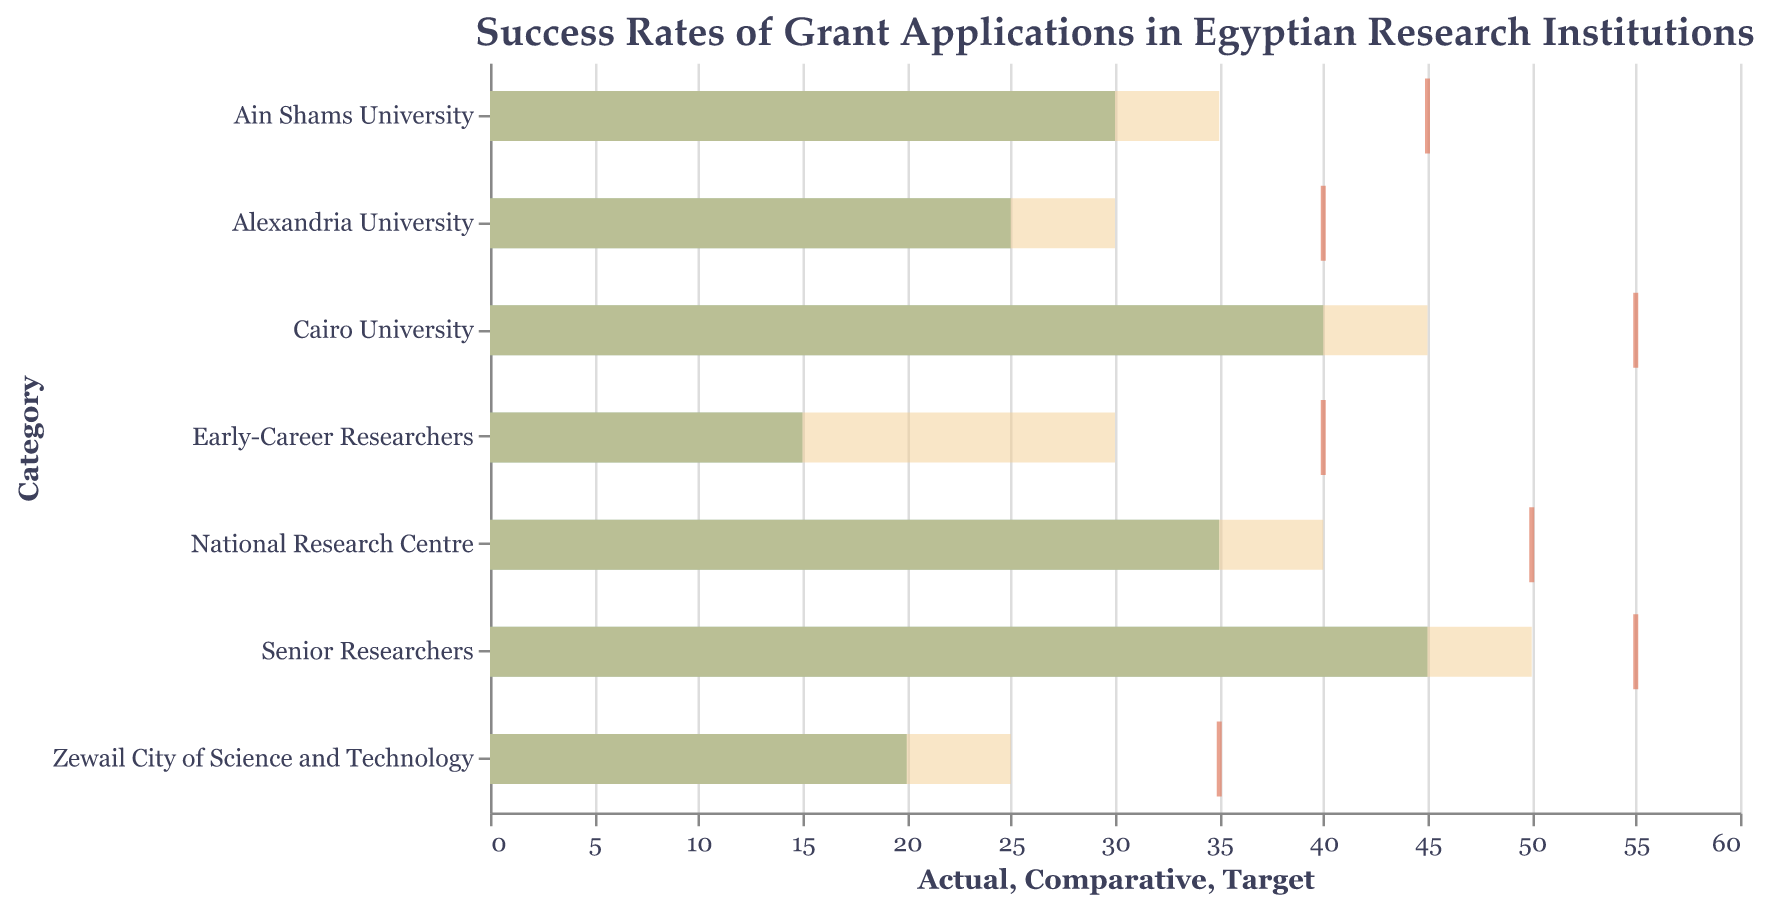What is the actual success rate for early-career researchers? Look at the "Actual" success rate bar associated with the "Early-Career Researchers" category.
Answer: 15 How does the actual success rate of senior researchers compare to the early-career researchers? Compare the "Actual" success rate bars for both categories. The senior researchers have 45, while the early-career researchers have 15.
Answer: Senior researchers have 30% higher success rate than early-career researchers Which institution has the lowest actual success rate? Look at the "Actual" success rate bars for all institutions. The institution with the smallest bar, "Zewail City of Science and Technology," has the lowest actual success rate.
Answer: Zewail City of Science and Technology Are any institutions meeting their target success rate? Compare the "Actual" success rate bars with their respective "Target" tick mark. None of the actual rates reach their target marks.
Answer: No What is the difference between the comparative and actual success rates for Cairo University? Subtract the "Actual" success rate from the "Comparative" success rate for Cairo University (45 - 40).
Answer: 5 Which institution is closest to meeting its target success rate? Compare the distances between the "Actual" success rate bars and the "Target" tick marks. Cairo University is the closest as it's 15% away from its target of 55.
Answer: Cairo University How does the success rate of Ain Shams University compare to Alexandria University in terms of their actual data? Look at the "Actual" success rate bars for both universities. Ain Shams University has 30, and Alexandria University has 25.
Answer: Ain Shams University's rate is 5% higher What is the combined actual success rate of the National Research Centre and Zewail City of Science and Technology? Add the "Actual" success rates for both categories (35 + 20).
Answer: 55 Which category or institution has the highest actual success rate? Identify the tallest "Actual" success rate bar in the chart. The "Senior Researchers" category has the highest actual success rate.
Answer: Senior Researchers How does the comparative success rate for senior researchers differ from that of early-career researchers? Subtract the "Comparative" success rate of early-career researchers from that of senior researchers (50 - 30).
Answer: 20 